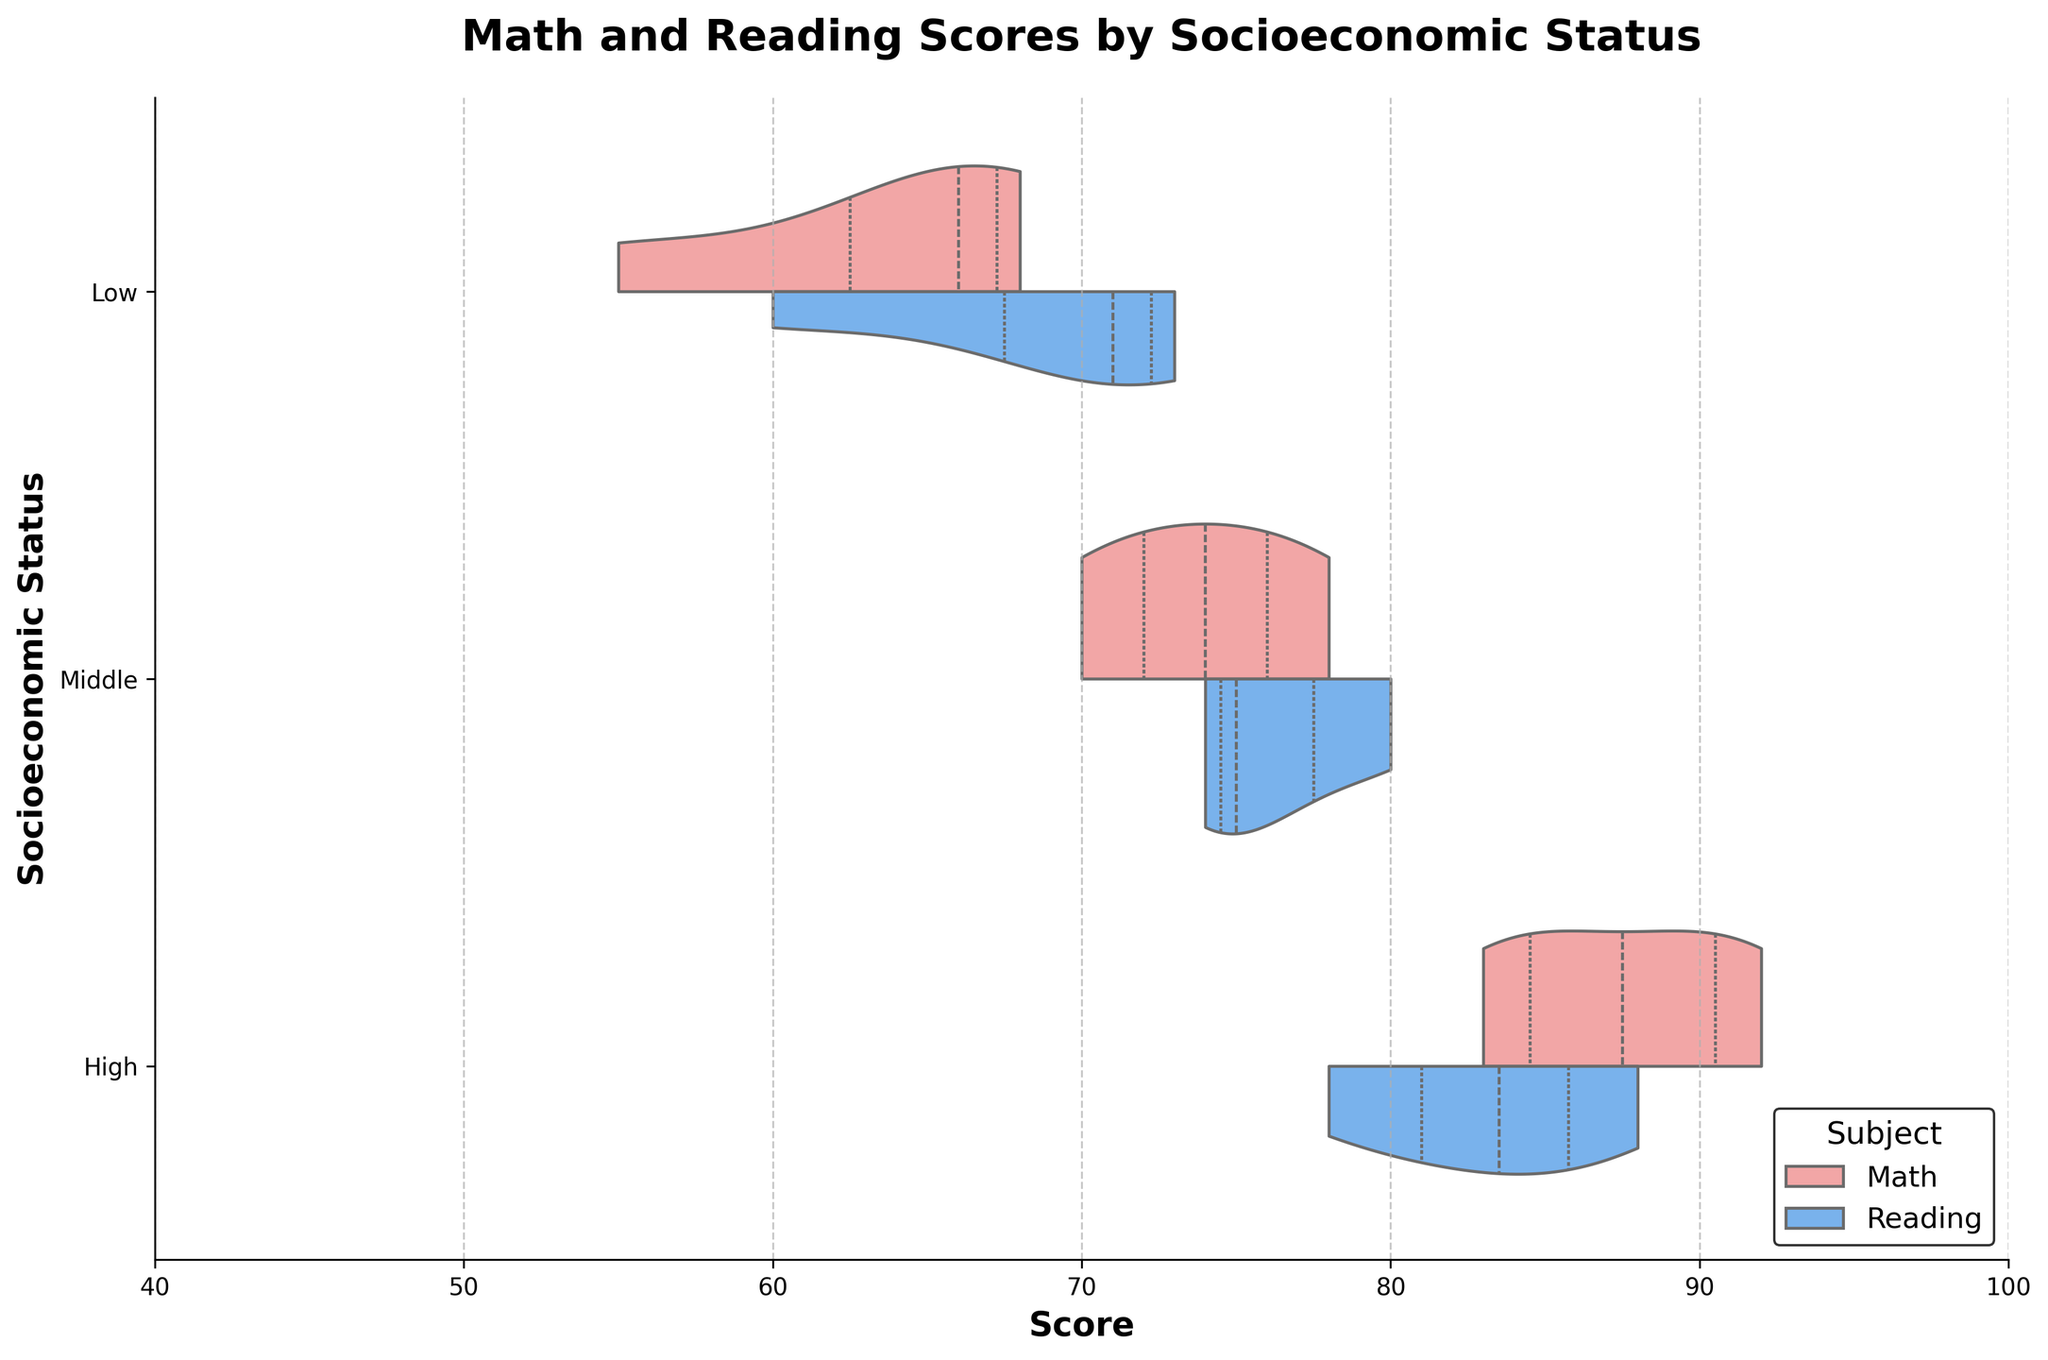What is the title of the figure? Look at the top of the plot; the title is displayed there and describes the main subject of the figure.
Answer: Math and Reading Scores by Socioeconomic Status What are the two subjects displayed in the figure? The legend on the right-hand side of the plot specifies the subjects represented with different colors.
Answer: Math and Reading Which socioeconomic status group has the highest median reading score? Observe the inner quartile lines within the 'Reading' side of the violin plots for each socioeconomic status group. Identify which group has the highest median line.
Answer: High How many socioeconomic status groups are there in the figure? The y-axis lists the socioeconomic status groups. Count the unique entries.
Answer: Three (Low, Middle, High) What is the range of scores displayed on the x-axis? Look at the x-axis labels to see the minimum and maximum score values.
Answer: 40 to 100 Which socioeconomic status group shows the widest spread of math scores? Compare the width of the violin plots for 'Math' across different socioeconomic status groups. The group with the widest plot has the widest spread.
Answer: Low In which subject and socioeconomic status group are the scores most tightly clustered around the median? Look at the violin plots for both Math and Reading across all socioeconomic groups; the tightest clustering will be indicated by the narrowest violins around the median line.
Answer: Reading, High How do the median math scores for the 'Middle' socioeconomic group compare to the 'Low' and 'High' groups? Focus on the inner quartile line representing the median within the math section of each plot, then compare these positions across the three groups.
Answer: Higher than Low, Lower than High What is the interquartile range (IQR) of math scores for the 'Middle' socioeconomic status group? Observe the inner quartile lines on the 'Math' side of the violin plot for 'Middle' socioeconomic group. The IQR is the distance between the first and third quartiles.
Answer: Approx. 70 to 78 Which socioeconomic status group shows the greatest difference between the scores in Math and Reading? Compare the positions, widths, and spreads of the violins for Math and Reading in each socioeconomic status group, and identify the group with the most noticeable difference.
Answer: Low 